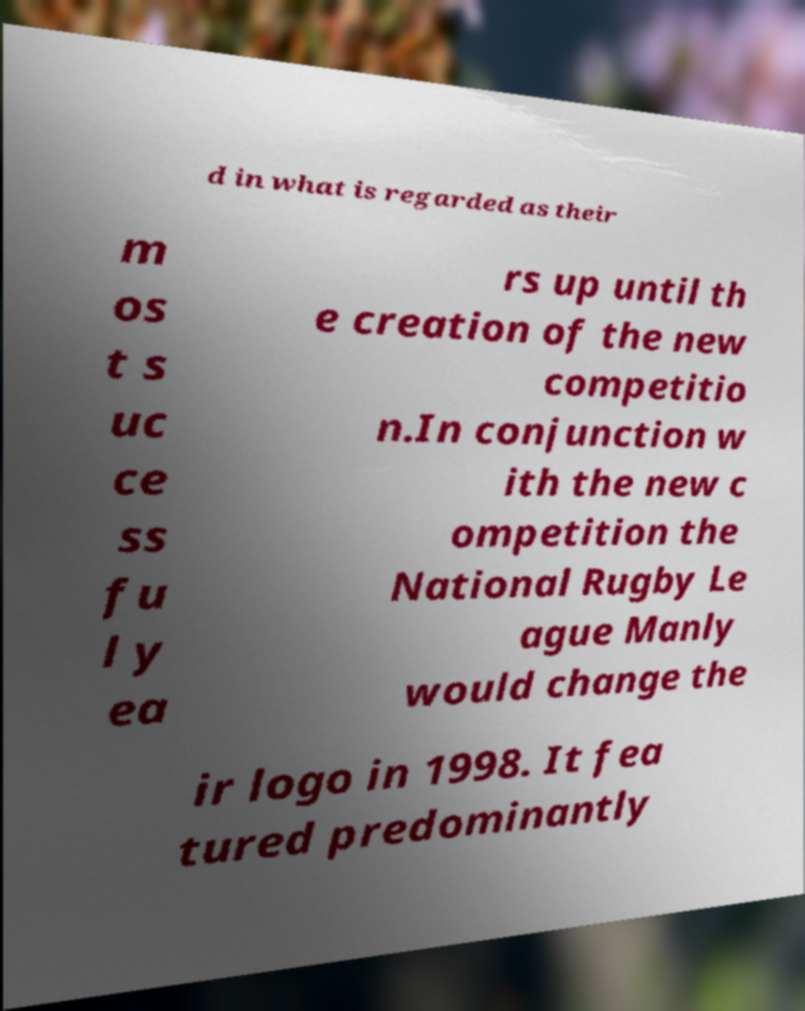There's text embedded in this image that I need extracted. Can you transcribe it verbatim? d in what is regarded as their m os t s uc ce ss fu l y ea rs up until th e creation of the new competitio n.In conjunction w ith the new c ompetition the National Rugby Le ague Manly would change the ir logo in 1998. It fea tured predominantly 